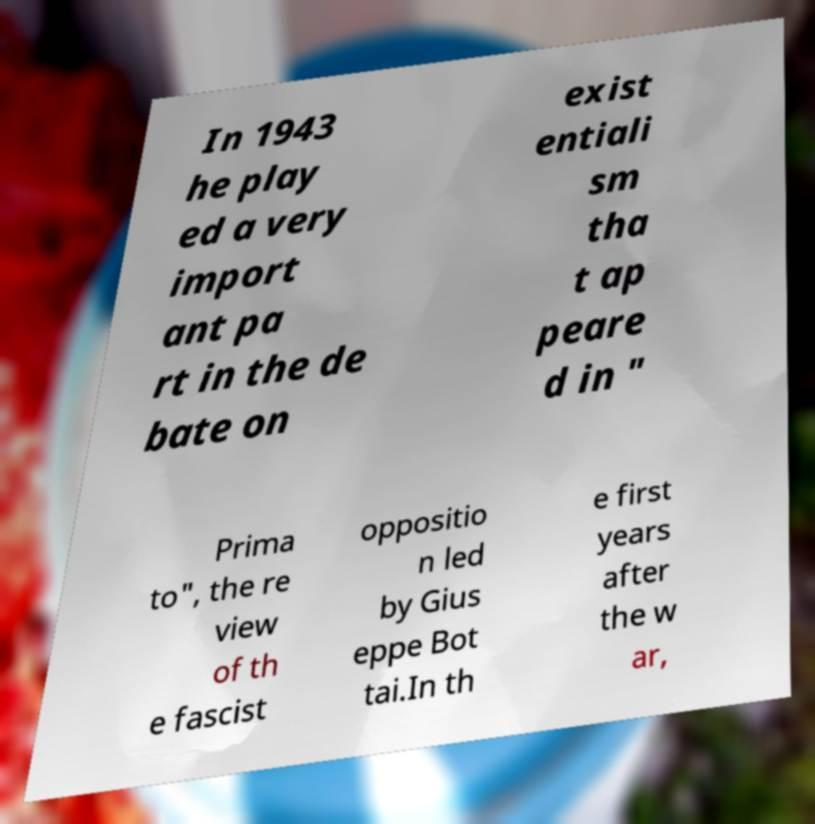Could you extract and type out the text from this image? In 1943 he play ed a very import ant pa rt in the de bate on exist entiali sm tha t ap peare d in " Prima to", the re view of th e fascist oppositio n led by Gius eppe Bot tai.In th e first years after the w ar, 